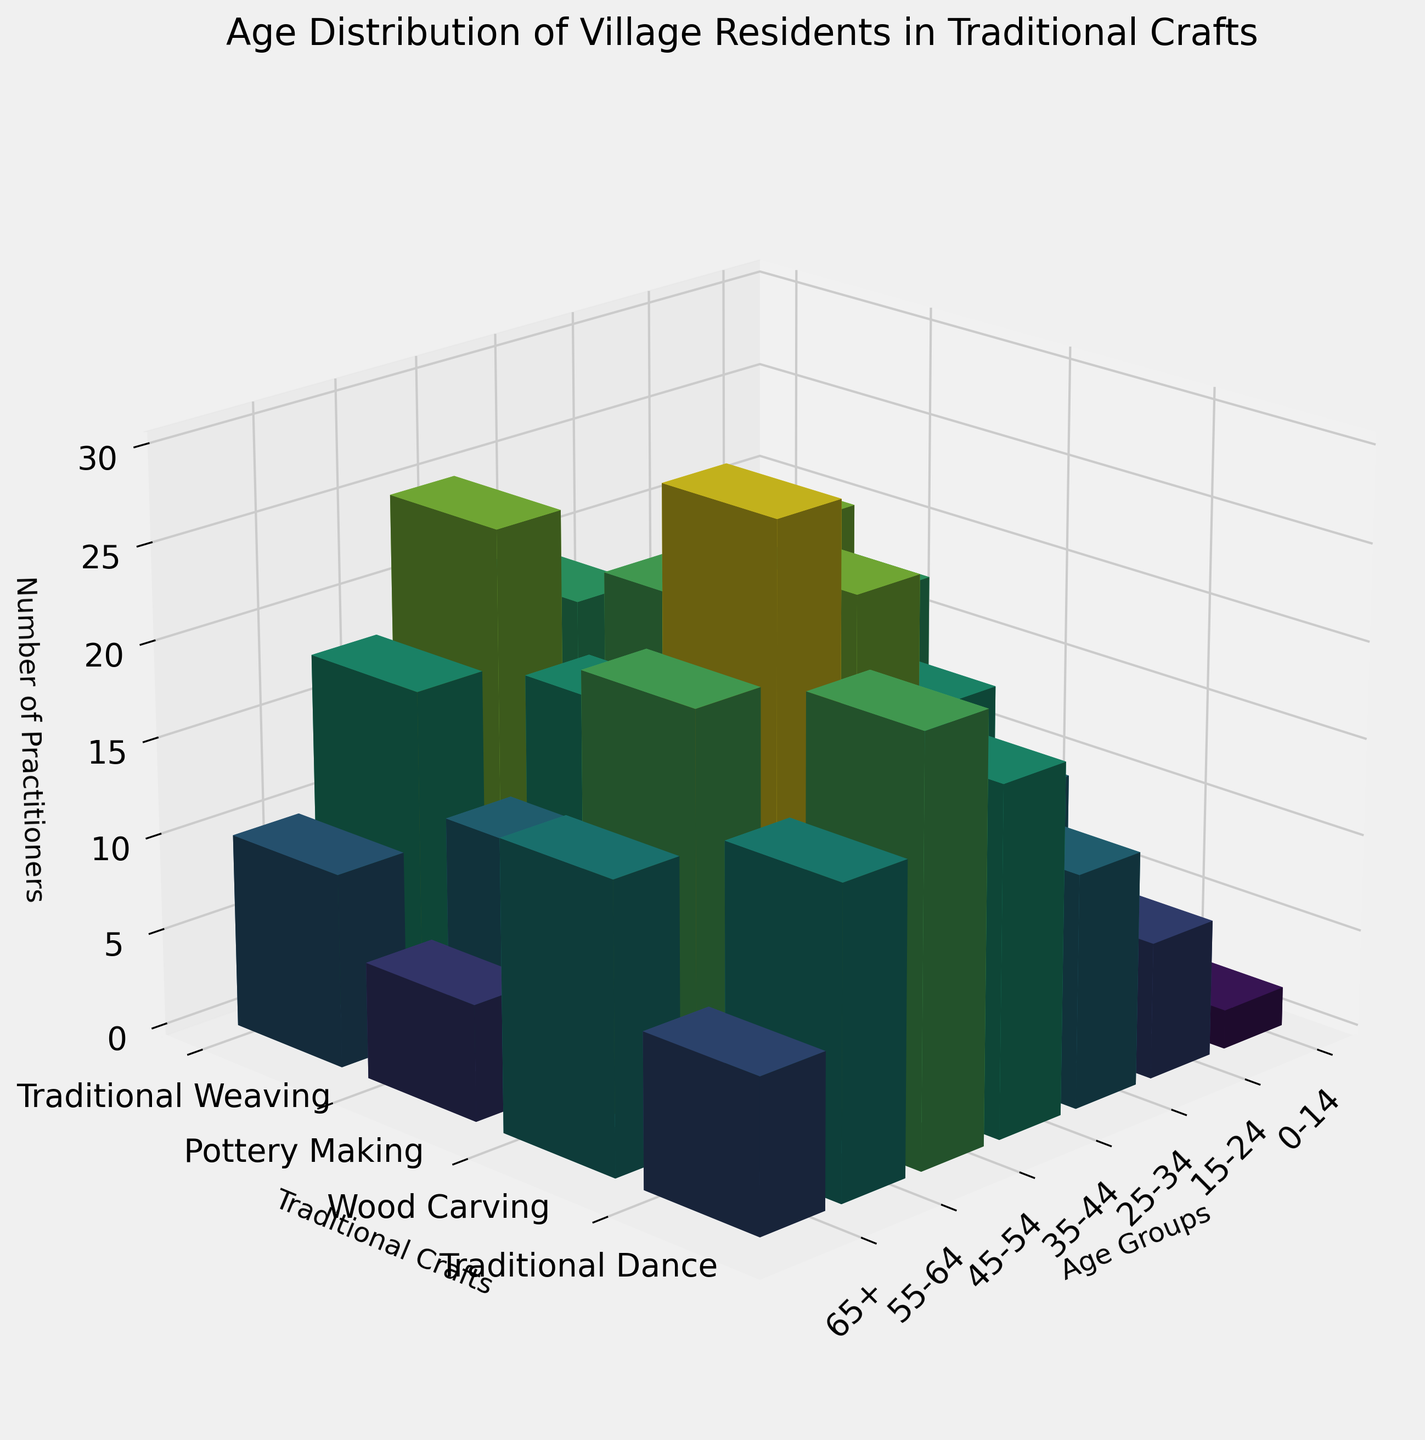What is the title of the figure? The title of the figure is written at the top and helps to identify the subject of the visualization.
Answer: Age Distribution of Village Residents in Traditional Crafts What age group has the fewest practitioners in Traditional Weaving? Looking at the bars for Traditional Weaving, the shortest bar represents the fewest practitioners. The 0-14 age group has the smallest bar for Traditional Weaving.
Answer: 0-14 How many practitioners are there in the 35-44 age group for Pottery Making? By locating the 35-44 age group on the x-axis and finding the corresponding bar for Pottery Making on the y-axis, the height of the bar shows the number of practitioners.
Answer: 20 Which traditional craft has the highest number of practitioners in the 45-54 age group? Find the 45-54 age group on the x-axis and compare the heights of the bars corresponding to each craft on the y-axis. Traditional Weaving has the tallest bar.
Answer: Traditional Weaving What is the total number of practitioners aged 55-64 across all crafts? Sum the heights of the bars for the 55-64 age group across all crafts: Traditional Weaving (22) + Pottery Making (18) + Wood Carving (16) + Traditional Dance (12). The total is 68.
Answer: 68 Which craft has the highest variation in the number of practitioners across different age groups? Compare the height differences of bars for each craft across age groups. Traditional Weaving has the highest variation in bar heights.
Answer: Traditional Weaving In which age group do Traditional Dance practitioners outnumber Traditional Weaving practitioners? Compare the heights of the bars for Traditional Dance and Traditional Weaving for each age group. The 0-14 age group has more practitioners in Traditional Dance than in Traditional Weaving.
Answer: 0-14 Is there a general trend in the number of Wood Carving practitioners by age group? Observe the pattern of bar heights for Wood Carving across age groups; it increases with age up to 35-44 and then decreases.
Answer: Increases then decreases What is the ratio of 15-24 age group practitioners of Traditional Dance to those of Pottery Making? Divide the number of 15-24 age group practitioners in Traditional Dance (20) by the number in Pottery Making (8). The ratio is 20/8.
Answer: 2.5 Which craft consistently has fewer practitioners than others in the 65+ age group? Compare the bar heights of each craft in the 65+ age group; Wood Carving has the consistently shorter bar.
Answer: Wood Carving 